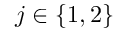<formula> <loc_0><loc_0><loc_500><loc_500>j \in \{ 1 , 2 \}</formula> 